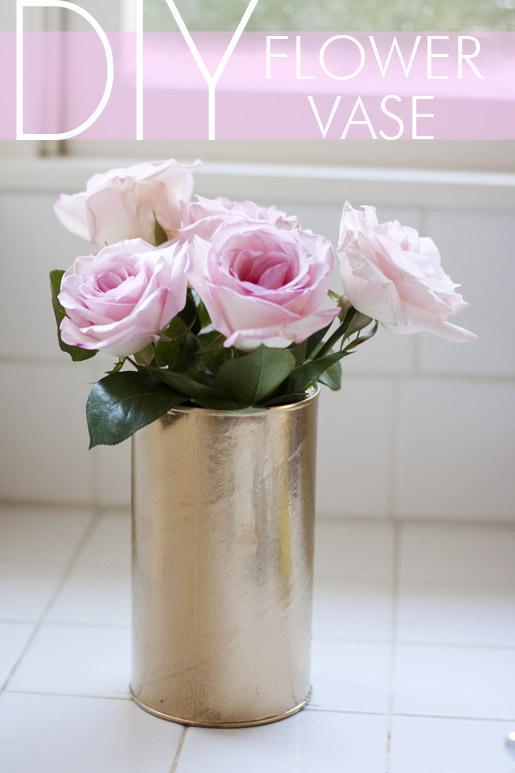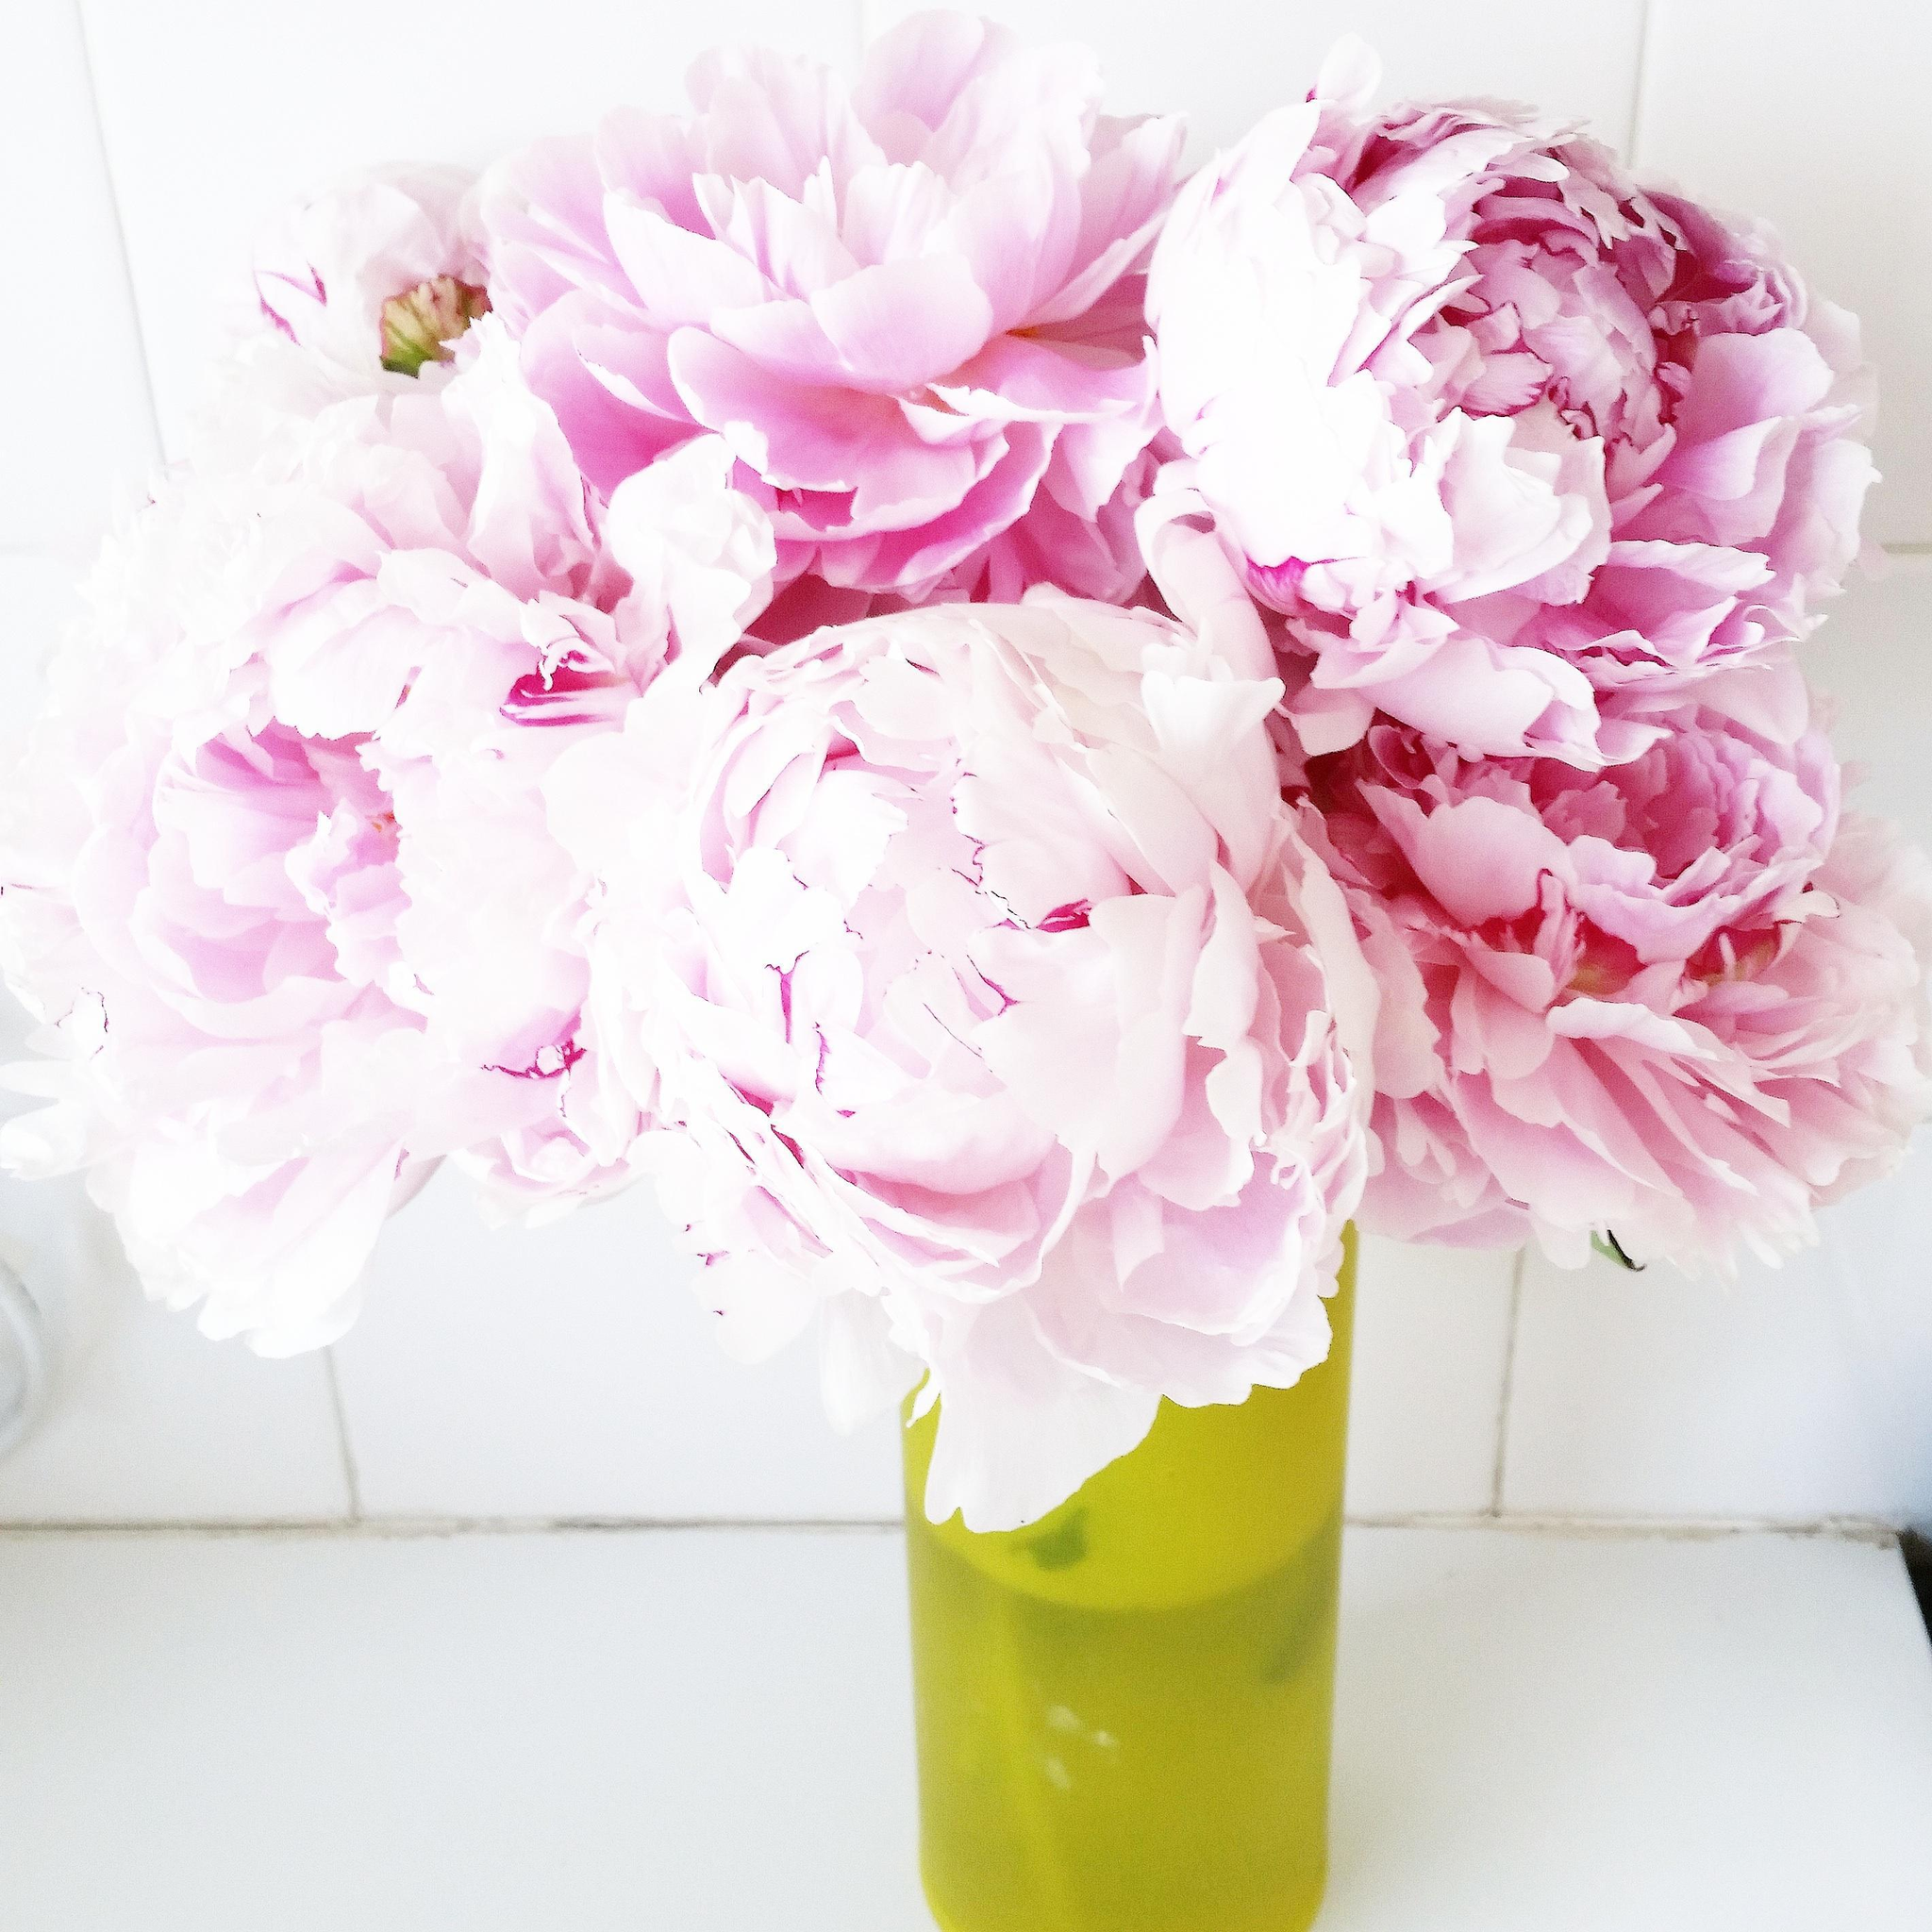The first image is the image on the left, the second image is the image on the right. Examine the images to the left and right. Is the description "A bunch of green stems are visible through the glass in the vase on the right." accurate? Answer yes or no. No. 